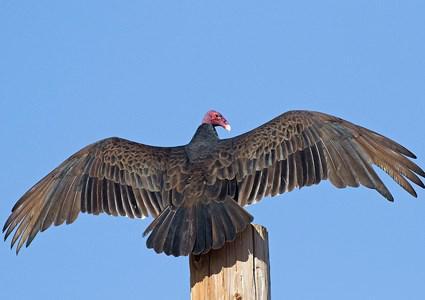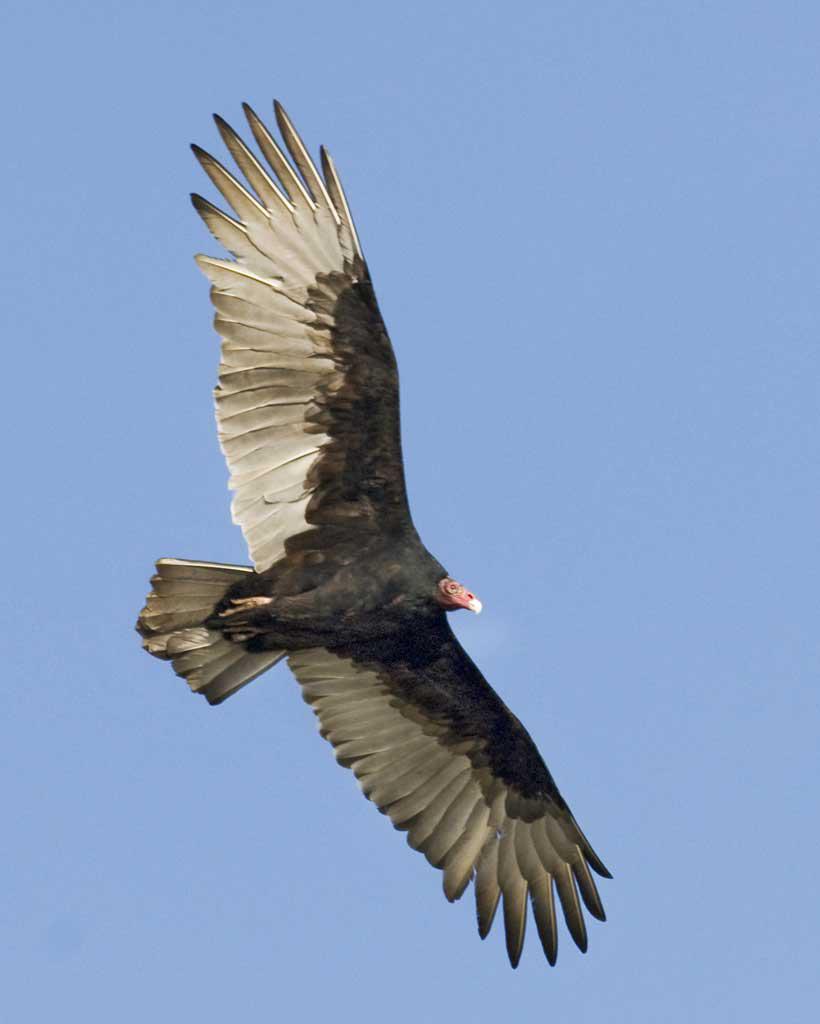The first image is the image on the left, the second image is the image on the right. For the images shown, is this caption "Both birds are facing the same direction." true? Answer yes or no. No. The first image is the image on the left, the second image is the image on the right. Examine the images to the left and right. Is the description "the bird on the left image is facing right." accurate? Answer yes or no. No. 